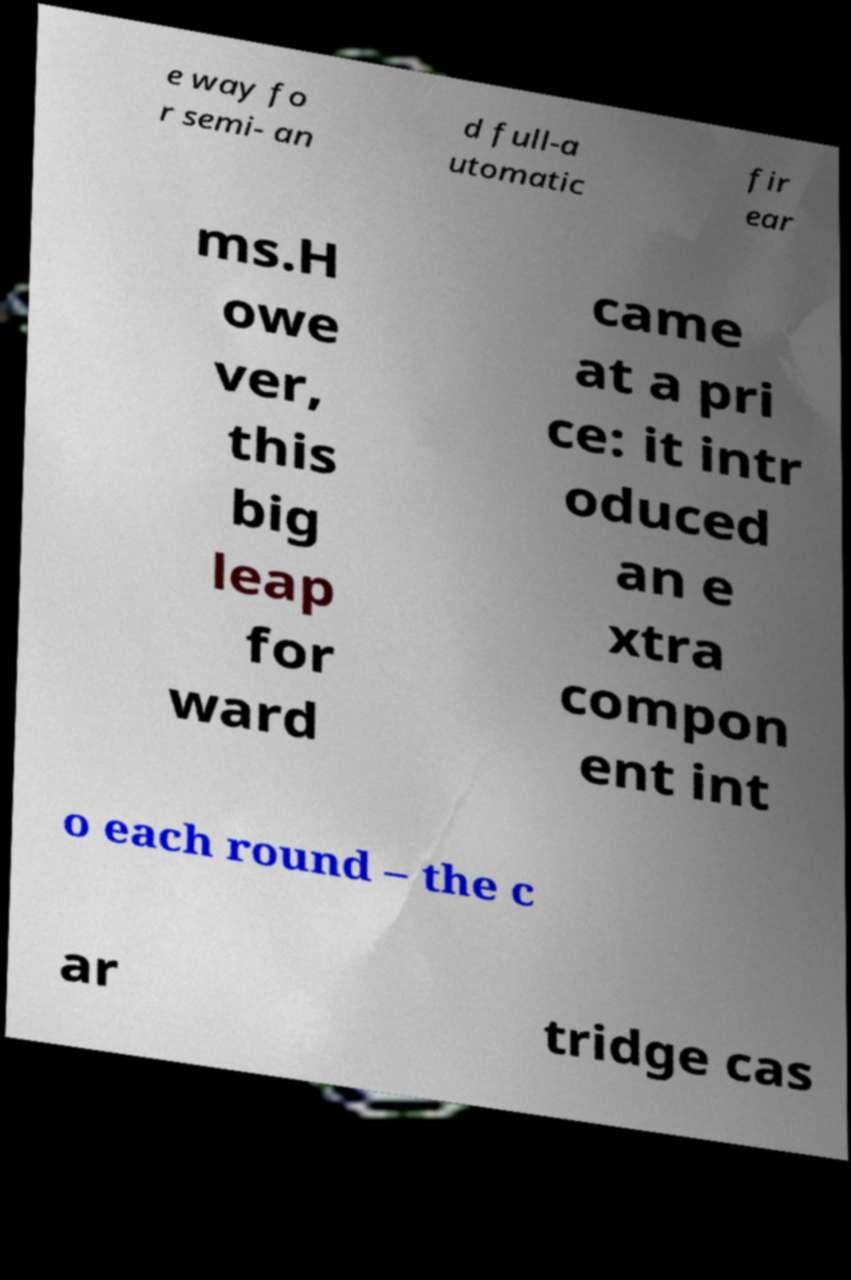Can you accurately transcribe the text from the provided image for me? e way fo r semi- an d full-a utomatic fir ear ms.H owe ver, this big leap for ward came at a pri ce: it intr oduced an e xtra compon ent int o each round – the c ar tridge cas 